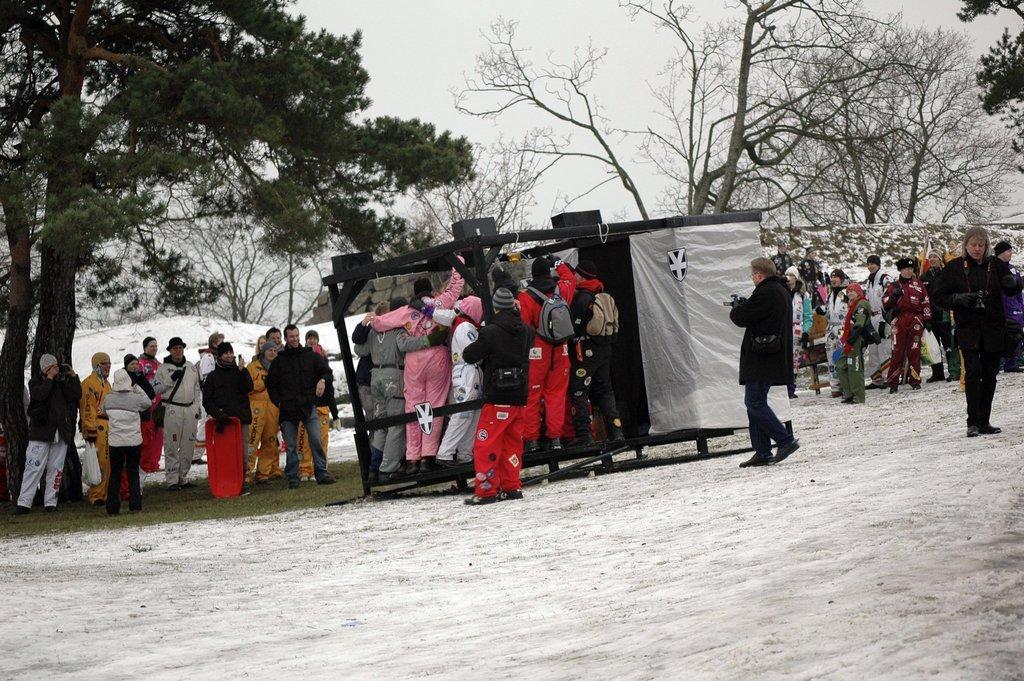Could you give a brief overview of what you see in this image? In this image, we can see trees and there are people wearing coats, caps and some are wearing bags and holding objects and we can see a shed. At the bottom, there is sand. 